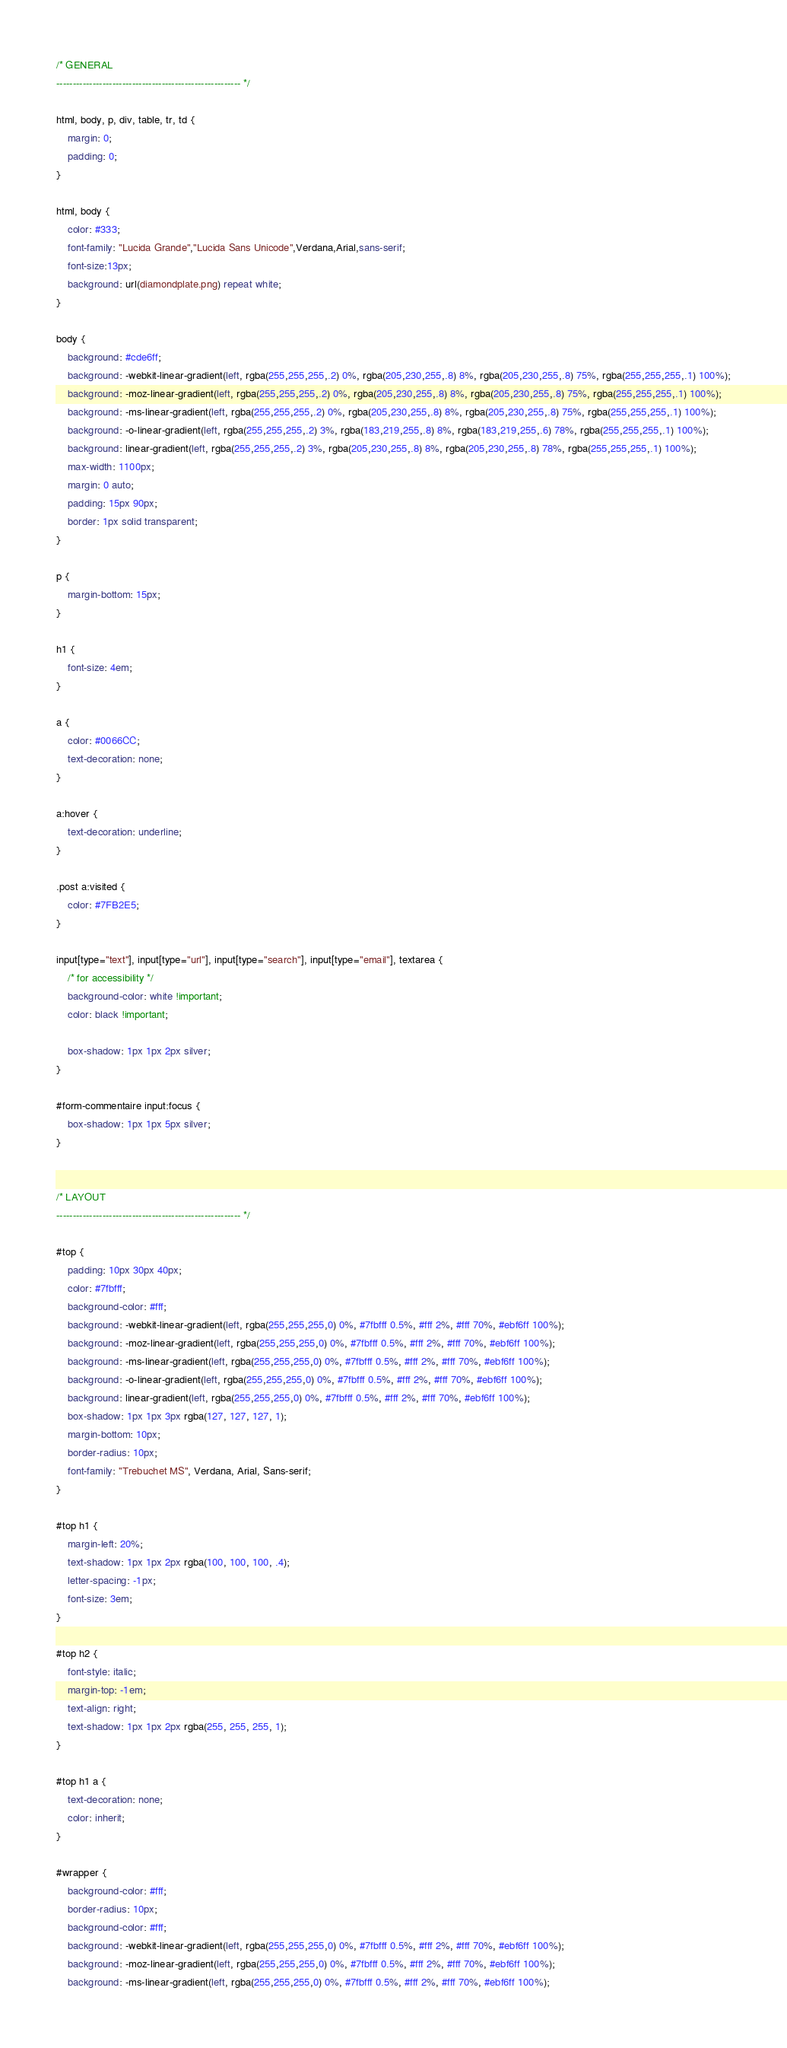<code> <loc_0><loc_0><loc_500><loc_500><_CSS_>
/* GENERAL
-------------------------------------------------------- */

html, body, p, div, table, tr, td {
	margin: 0;
	padding: 0;
}

html, body {
	color: #333;
	font-family: "Lucida Grande","Lucida Sans Unicode",Verdana,Arial,sans-serif; 
	font-size:13px;
	background: url(diamondplate.png) repeat white;
}

body {
	background: #cde6ff;
	background: -webkit-linear-gradient(left, rgba(255,255,255,.2) 0%, rgba(205,230,255,.8) 8%, rgba(205,230,255,.8) 75%, rgba(255,255,255,.1) 100%);
	background: -moz-linear-gradient(left, rgba(255,255,255,.2) 0%, rgba(205,230,255,.8) 8%, rgba(205,230,255,.8) 75%, rgba(255,255,255,.1) 100%);
	background: -ms-linear-gradient(left, rgba(255,255,255,.2) 0%, rgba(205,230,255,.8) 8%, rgba(205,230,255,.8) 75%, rgba(255,255,255,.1) 100%);
	background: -o-linear-gradient(left, rgba(255,255,255,.2) 3%, rgba(183,219,255,.8) 8%, rgba(183,219,255,.6) 78%, rgba(255,255,255,.1) 100%);
	background: linear-gradient(left, rgba(255,255,255,.2) 3%, rgba(205,230,255,.8) 8%, rgba(205,230,255,.8) 78%, rgba(255,255,255,.1) 100%);
	max-width: 1100px;
	margin: 0 auto;
	padding: 15px 90px;
	border: 1px solid transparent;
}

p {
	margin-bottom: 15px;
}

h1 {
	font-size: 4em;
}

a {
	color: #0066CC;
	text-decoration: none;
}

a:hover {
	text-decoration: underline;
}

.post a:visited {
	color: #7FB2E5;
}

input[type="text"], input[type="url"], input[type="search"], input[type="email"], textarea {
	/* for accessibility */
	background-color: white !important;
	color: black !important;

	box-shadow: 1px 1px 2px silver;
}

#form-commentaire input:focus {
	box-shadow: 1px 1px 5px silver;
}


/* LAYOUT
-------------------------------------------------------- */

#top {
	padding: 10px 30px 40px;
	color: #7fbfff;
	background-color: #fff;
	background: -webkit-linear-gradient(left, rgba(255,255,255,0) 0%, #7fbfff 0.5%, #fff 2%, #fff 70%, #ebf6ff 100%);
	background: -moz-linear-gradient(left, rgba(255,255,255,0) 0%, #7fbfff 0.5%, #fff 2%, #fff 70%, #ebf6ff 100%);
	background: -ms-linear-gradient(left, rgba(255,255,255,0) 0%, #7fbfff 0.5%, #fff 2%, #fff 70%, #ebf6ff 100%);
	background: -o-linear-gradient(left, rgba(255,255,255,0) 0%, #7fbfff 0.5%, #fff 2%, #fff 70%, #ebf6ff 100%);
	background: linear-gradient(left, rgba(255,255,255,0) 0%, #7fbfff 0.5%, #fff 2%, #fff 70%, #ebf6ff 100%);
	box-shadow: 1px 1px 3px rgba(127, 127, 127, 1);
	margin-bottom: 10px;
	border-radius: 10px;
	font-family: "Trebuchet MS", Verdana, Arial, Sans-serif;
}

#top h1 {
	margin-left: 20%;
	text-shadow: 1px 1px 2px rgba(100, 100, 100, .4);
	letter-spacing: -1px;
	font-size: 3em;
}

#top h2 {
	font-style: italic;
	margin-top: -1em;
	text-align: right;
	text-shadow: 1px 1px 2px rgba(255, 255, 255, 1);
}

#top h1 a {
	text-decoration: none;
	color: inherit;
}

#wrapper {
	background-color: #fff;
	border-radius: 10px;
	background-color: #fff;
	background: -webkit-linear-gradient(left, rgba(255,255,255,0) 0%, #7fbfff 0.5%, #fff 2%, #fff 70%, #ebf6ff 100%);
	background: -moz-linear-gradient(left, rgba(255,255,255,0) 0%, #7fbfff 0.5%, #fff 2%, #fff 70%, #ebf6ff 100%);
	background: -ms-linear-gradient(left, rgba(255,255,255,0) 0%, #7fbfff 0.5%, #fff 2%, #fff 70%, #ebf6ff 100%);</code> 